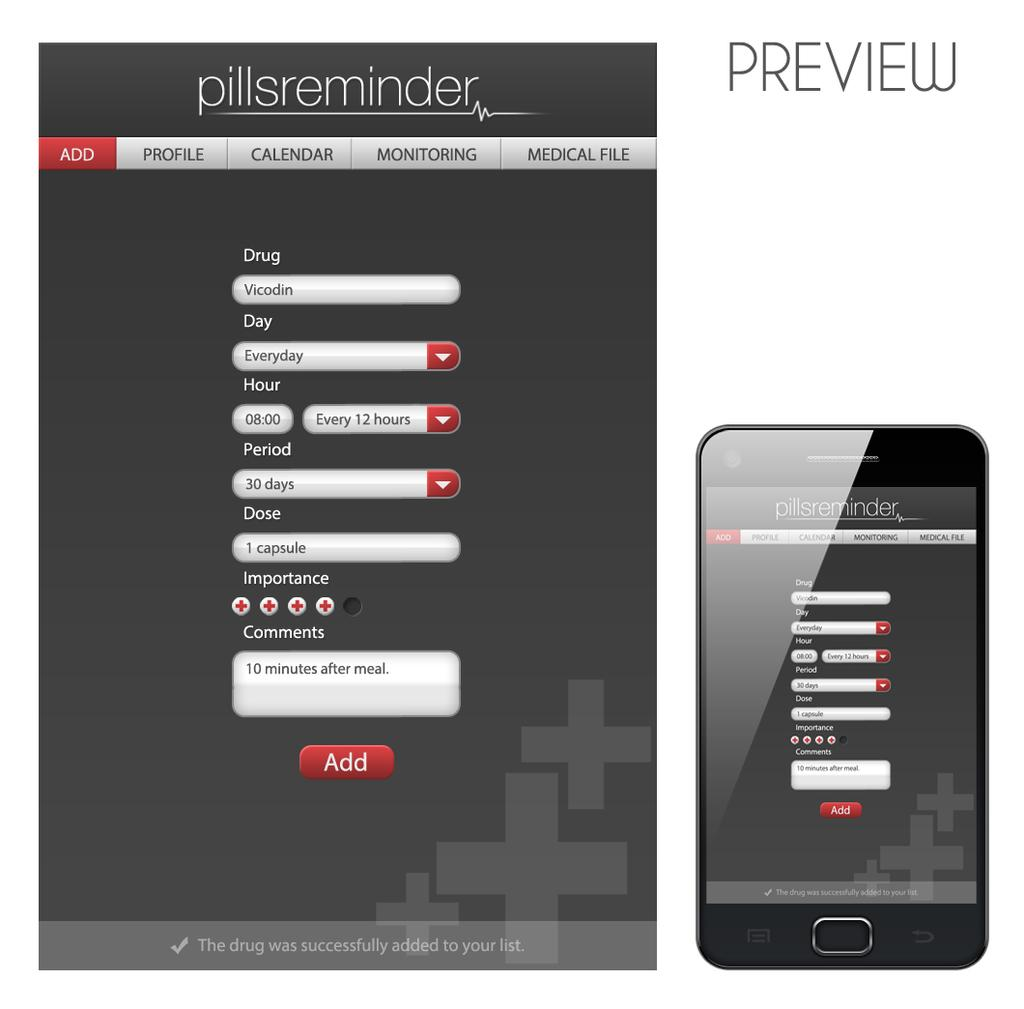<image>
Share a concise interpretation of the image provided. The app shown is a pillsreminder add that reminds a person when to take their medication. 